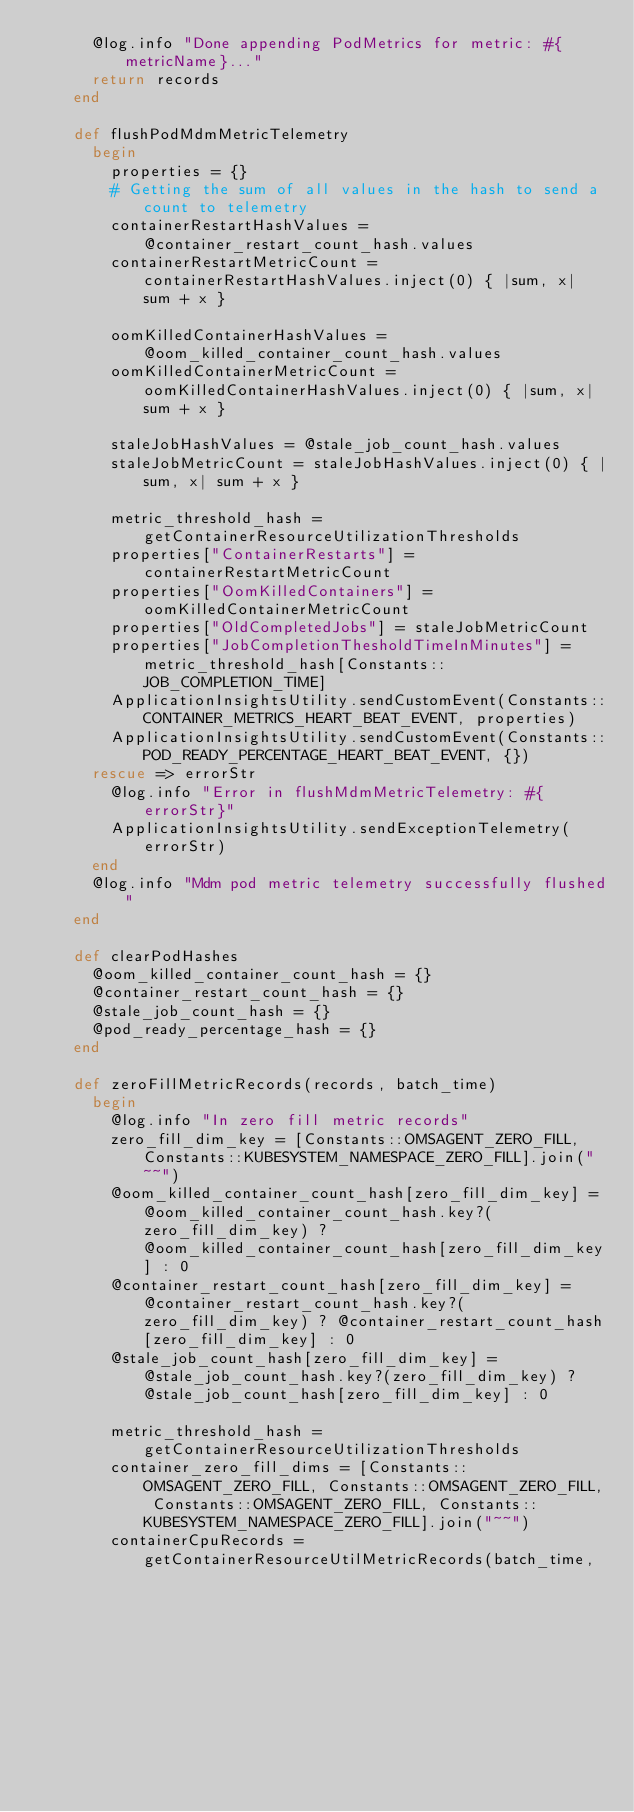<code> <loc_0><loc_0><loc_500><loc_500><_Ruby_>      @log.info "Done appending PodMetrics for metric: #{metricName}..."
      return records
    end

    def flushPodMdmMetricTelemetry
      begin
        properties = {}
        # Getting the sum of all values in the hash to send a count to telemetry
        containerRestartHashValues = @container_restart_count_hash.values
        containerRestartMetricCount = containerRestartHashValues.inject(0) { |sum, x| sum + x }

        oomKilledContainerHashValues = @oom_killed_container_count_hash.values
        oomKilledContainerMetricCount = oomKilledContainerHashValues.inject(0) { |sum, x| sum + x }

        staleJobHashValues = @stale_job_count_hash.values
        staleJobMetricCount = staleJobHashValues.inject(0) { |sum, x| sum + x }

        metric_threshold_hash = getContainerResourceUtilizationThresholds
        properties["ContainerRestarts"] = containerRestartMetricCount
        properties["OomKilledContainers"] = oomKilledContainerMetricCount
        properties["OldCompletedJobs"] = staleJobMetricCount
        properties["JobCompletionThesholdTimeInMinutes"] = metric_threshold_hash[Constants::JOB_COMPLETION_TIME]
        ApplicationInsightsUtility.sendCustomEvent(Constants::CONTAINER_METRICS_HEART_BEAT_EVENT, properties)
        ApplicationInsightsUtility.sendCustomEvent(Constants::POD_READY_PERCENTAGE_HEART_BEAT_EVENT, {})
      rescue => errorStr
        @log.info "Error in flushMdmMetricTelemetry: #{errorStr}"
        ApplicationInsightsUtility.sendExceptionTelemetry(errorStr)
      end
      @log.info "Mdm pod metric telemetry successfully flushed"
    end

    def clearPodHashes
      @oom_killed_container_count_hash = {}
      @container_restart_count_hash = {}
      @stale_job_count_hash = {}
      @pod_ready_percentage_hash = {}
    end

    def zeroFillMetricRecords(records, batch_time)
      begin
        @log.info "In zero fill metric records"
        zero_fill_dim_key = [Constants::OMSAGENT_ZERO_FILL, Constants::KUBESYSTEM_NAMESPACE_ZERO_FILL].join("~~")
        @oom_killed_container_count_hash[zero_fill_dim_key] = @oom_killed_container_count_hash.key?(zero_fill_dim_key) ? @oom_killed_container_count_hash[zero_fill_dim_key] : 0
        @container_restart_count_hash[zero_fill_dim_key] = @container_restart_count_hash.key?(zero_fill_dim_key) ? @container_restart_count_hash[zero_fill_dim_key] : 0
        @stale_job_count_hash[zero_fill_dim_key] = @stale_job_count_hash.key?(zero_fill_dim_key) ? @stale_job_count_hash[zero_fill_dim_key] : 0

        metric_threshold_hash = getContainerResourceUtilizationThresholds
        container_zero_fill_dims = [Constants::OMSAGENT_ZERO_FILL, Constants::OMSAGENT_ZERO_FILL, Constants::OMSAGENT_ZERO_FILL, Constants::KUBESYSTEM_NAMESPACE_ZERO_FILL].join("~~")
        containerCpuRecords = getContainerResourceUtilMetricRecords(batch_time,
                                                                    Constants::CPU_USAGE_NANO_CORES,
                                                                    0,
                                                                    container_zero_fill_dims,</code> 